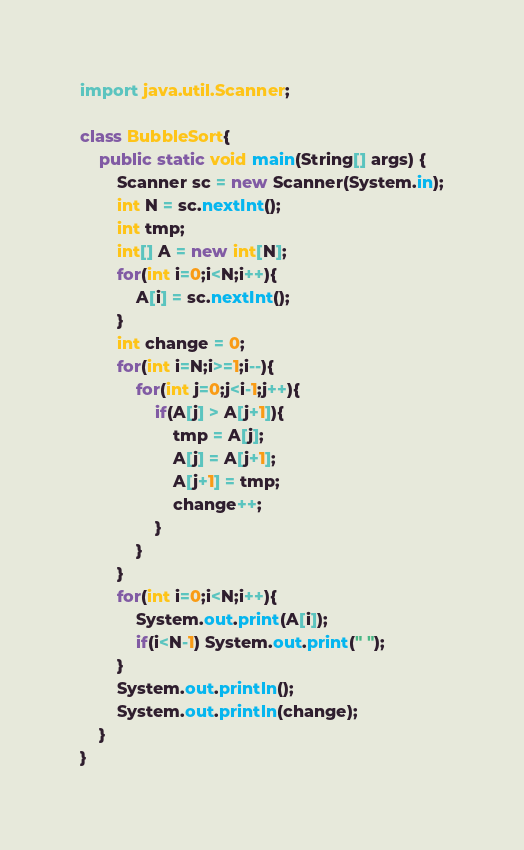Convert code to text. <code><loc_0><loc_0><loc_500><loc_500><_Java_>import java.util.Scanner;

class BubbleSort{
    public static void main(String[] args) {
        Scanner sc = new Scanner(System.in);
        int N = sc.nextInt();
        int tmp;
        int[] A = new int[N];
        for(int i=0;i<N;i++){
            A[i] = sc.nextInt();
        }
        int change = 0;
        for(int i=N;i>=1;i--){
            for(int j=0;j<i-1;j++){
                if(A[j] > A[j+1]){
                    tmp = A[j];
                    A[j] = A[j+1];
                    A[j+1] = tmp;
                    change++;
                }
            }
        }
        for(int i=0;i<N;i++){
            System.out.print(A[i]);
            if(i<N-1) System.out.print(" ");
        }
        System.out.println();
        System.out.println(change);
    }
}
</code> 